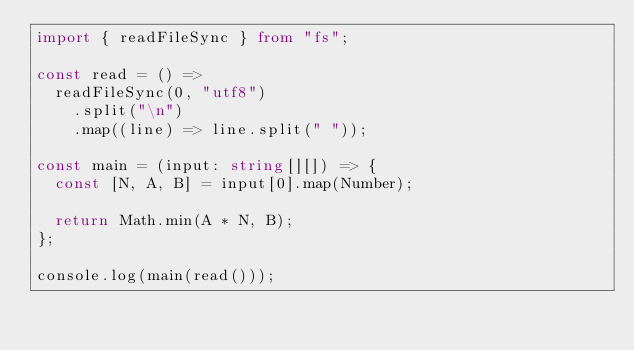<code> <loc_0><loc_0><loc_500><loc_500><_TypeScript_>import { readFileSync } from "fs";

const read = () =>
  readFileSync(0, "utf8")
    .split("\n")
    .map((line) => line.split(" "));

const main = (input: string[][]) => {
  const [N, A, B] = input[0].map(Number);

  return Math.min(A * N, B);
};

console.log(main(read()));
</code> 